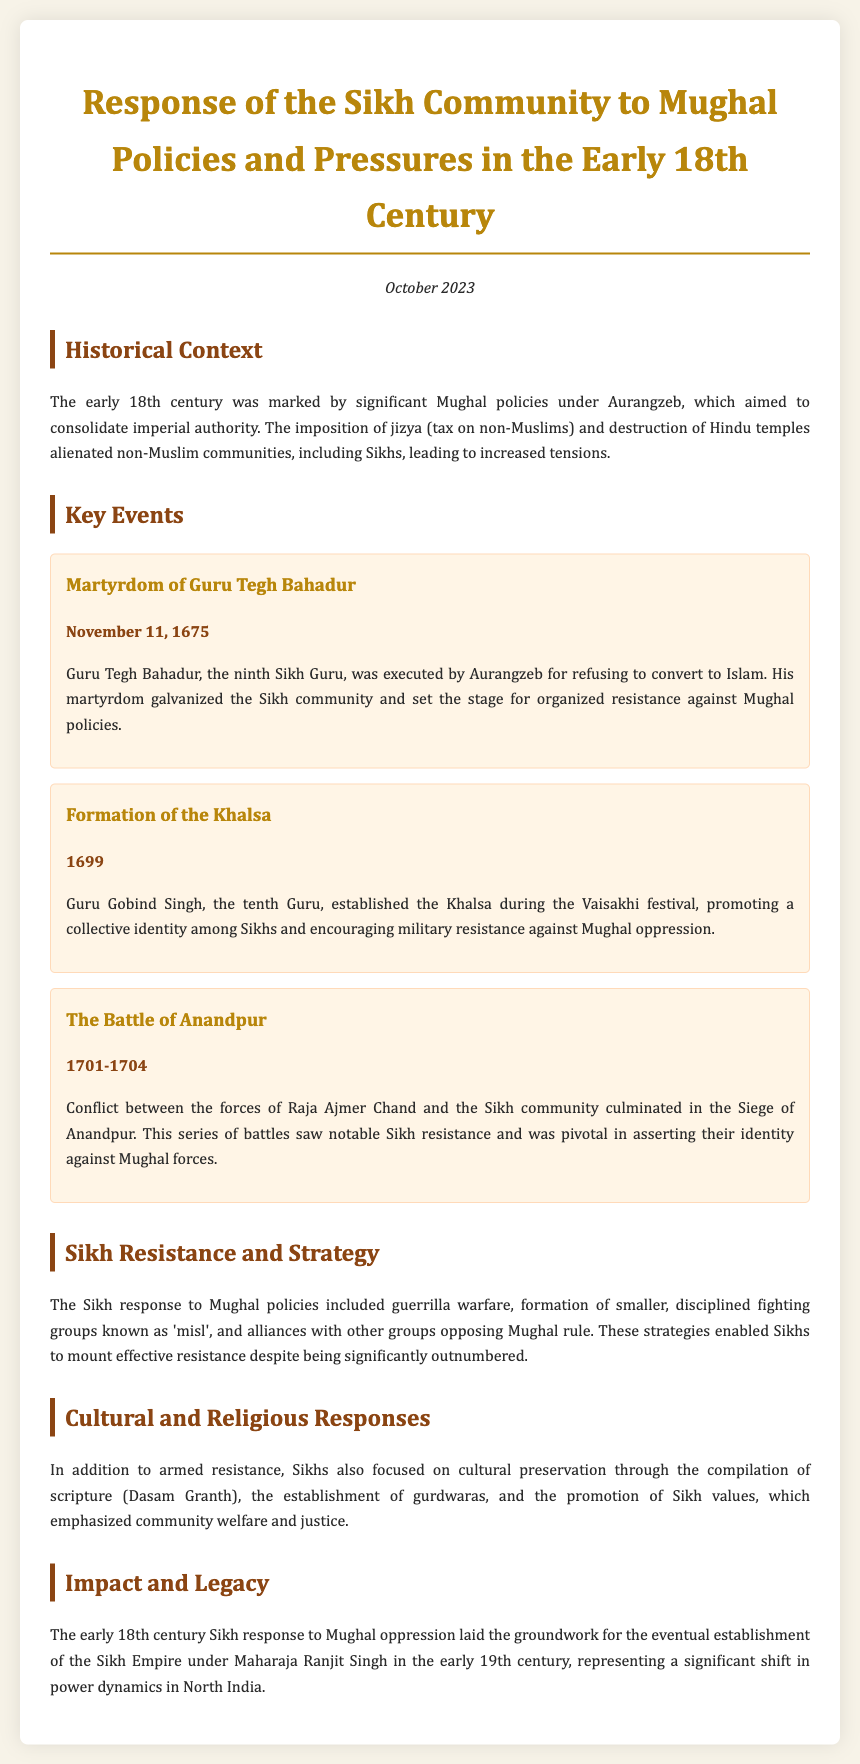What event marked the execution of Guru Tegh Bahadur? The document states that Guru Tegh Bahadur was executed on November 11, 1675.
Answer: November 11, 1675 Who established the Khalsa? According to the document, Guru Gobind Singh established the Khalsa during the Vaisakhi festival in 1699.
Answer: Guru Gobind Singh When did the Battle of Anandpur take place? The document indicates that the Battle of Anandpur occurred between 1701 and 1704.
Answer: 1701-1704 What strategy did Sikhs employ against Mughal forces? The document explains that Sikhs used guerrilla warfare and formed smaller disciplined groups known as 'misl'.
Answer: Guerrilla warfare What was a significant cultural response of the Sikh community? The document mentions the compilation of scripture (Dasam Granth) as a significant cultural response.
Answer: Dasam Granth 